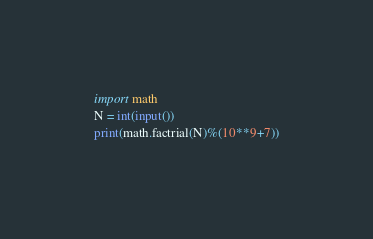Convert code to text. <code><loc_0><loc_0><loc_500><loc_500><_Python_>import math
N = int(input())
print(math.factrial(N)%(10**9+7))</code> 